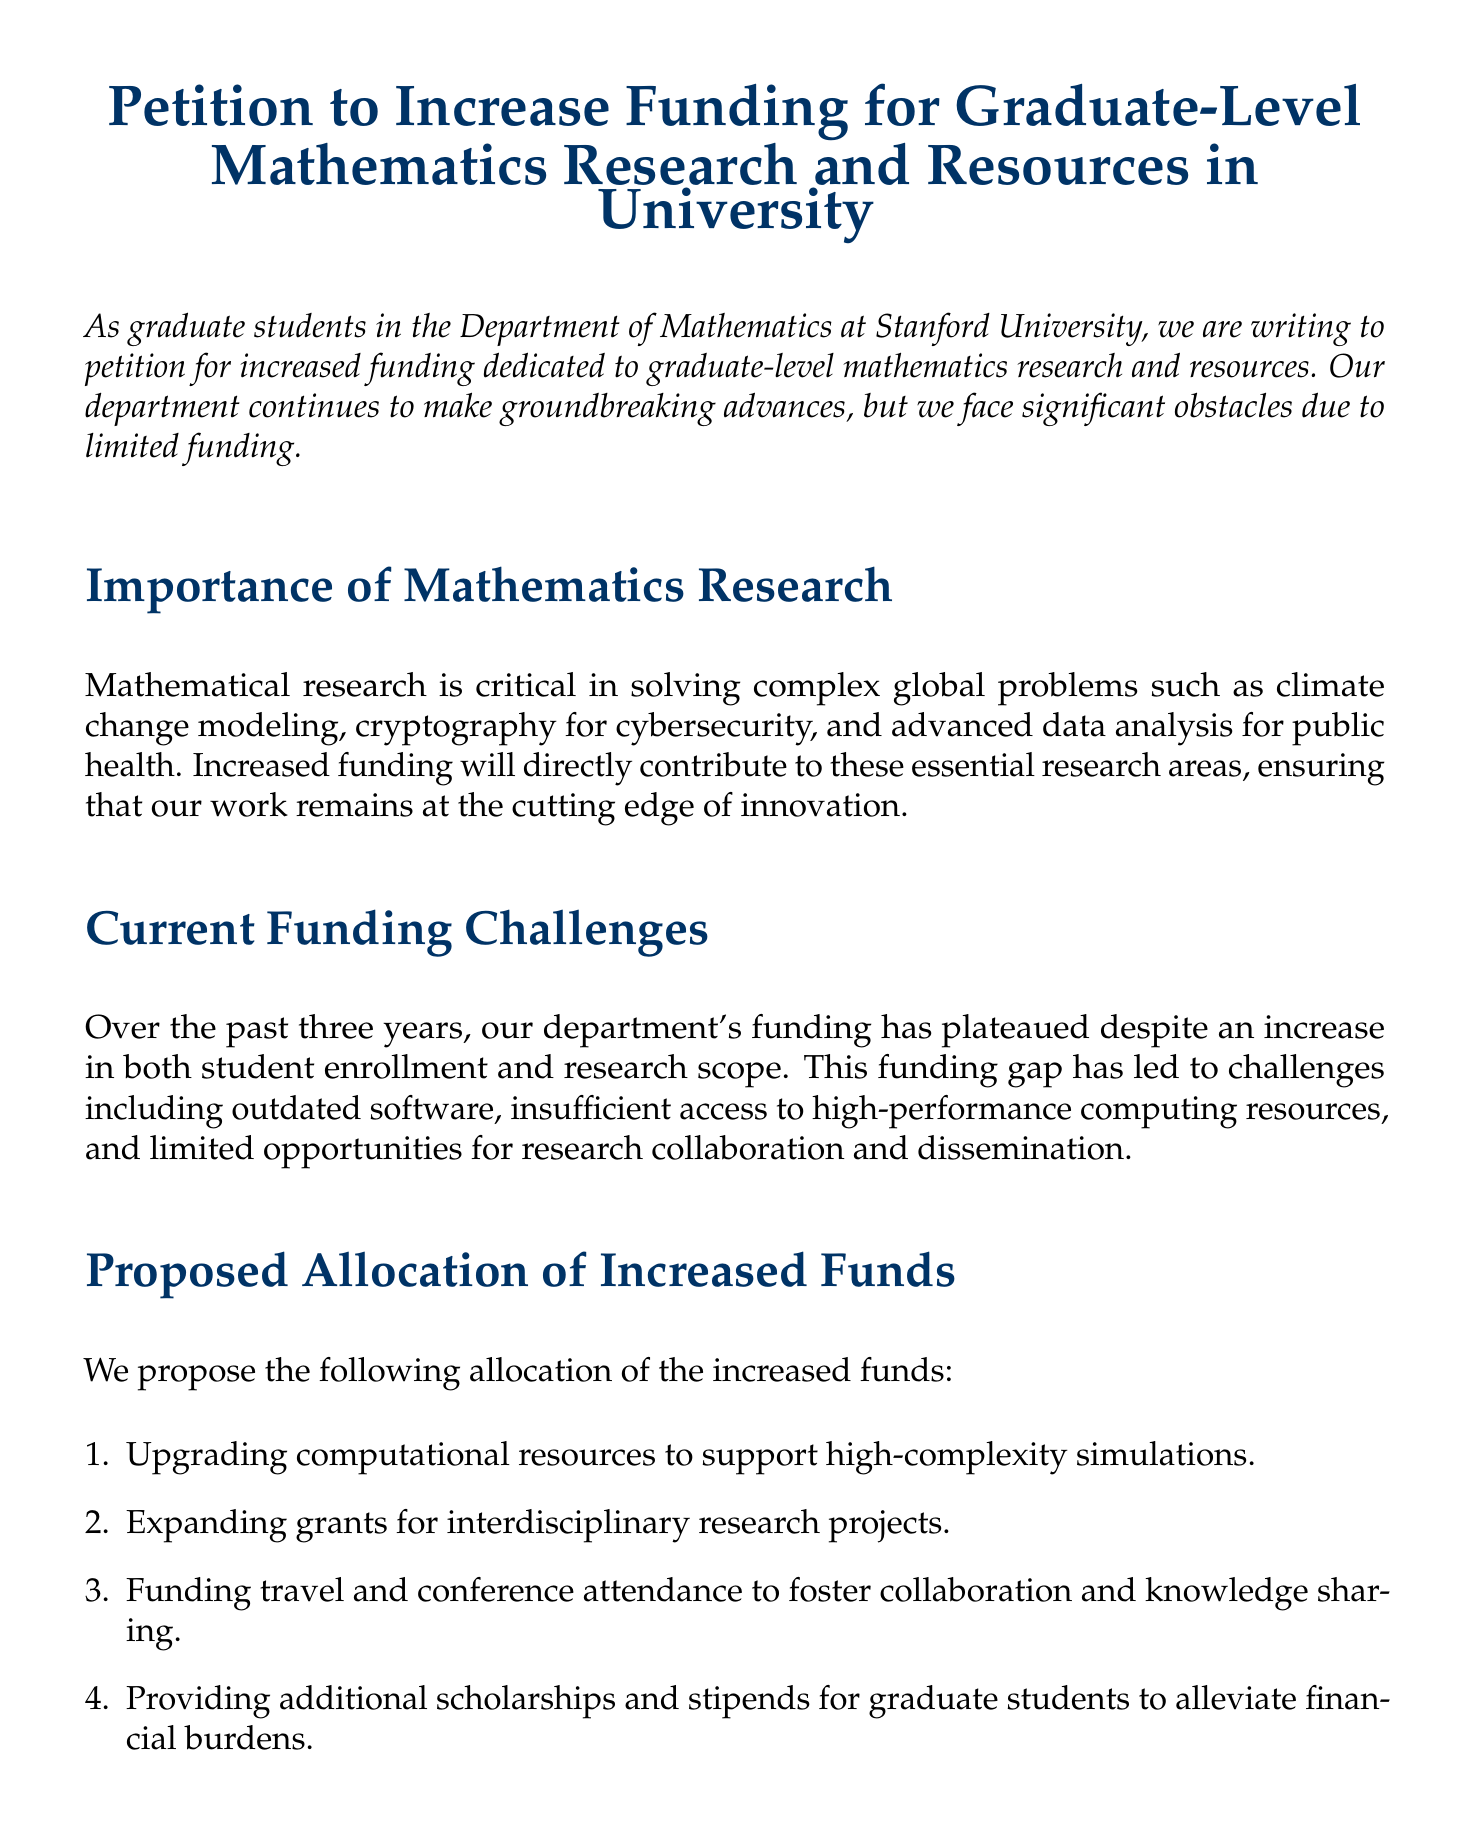What is the title of the petition? The title of the petition is explicitly stated at the beginning of the document.
Answer: Petition to Increase Funding for Graduate-Level Mathematics Research and Resources in University How many proposed allocations of increased funds are listed? The document explicitly enumerates the proposed allocations in a list format.
Answer: Four Who is one of the faculty members endorsing the petition? The petition mentions a specific faculty member as an endorser within the support section.
Answer: Professor Maryam Mirzakhani What problem has led to challenges within the department? The document describes the funding challenges faced by the department in detail.
Answer: Funding gap Which company leaders support this petition? The document identifies specific companies whose leaders have endorsed the petition.
Answer: Google and IBM What do the petitioners urge the University Administration to do? The document concludes with a clear call to action directed at the University Administration.
Answer: Allocate additional funding Who signed the petition as a graduate student besides John Doe? The document lists multiple signatories and identifies their roles.
Answer: Jane Smith What research area is explicitly mentioned as being important? The document highlights specific areas of research that require increased funding.
Answer: Climate change modeling 